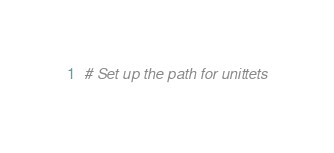<code> <loc_0><loc_0><loc_500><loc_500><_Python_># Set up the path for unittets</code> 